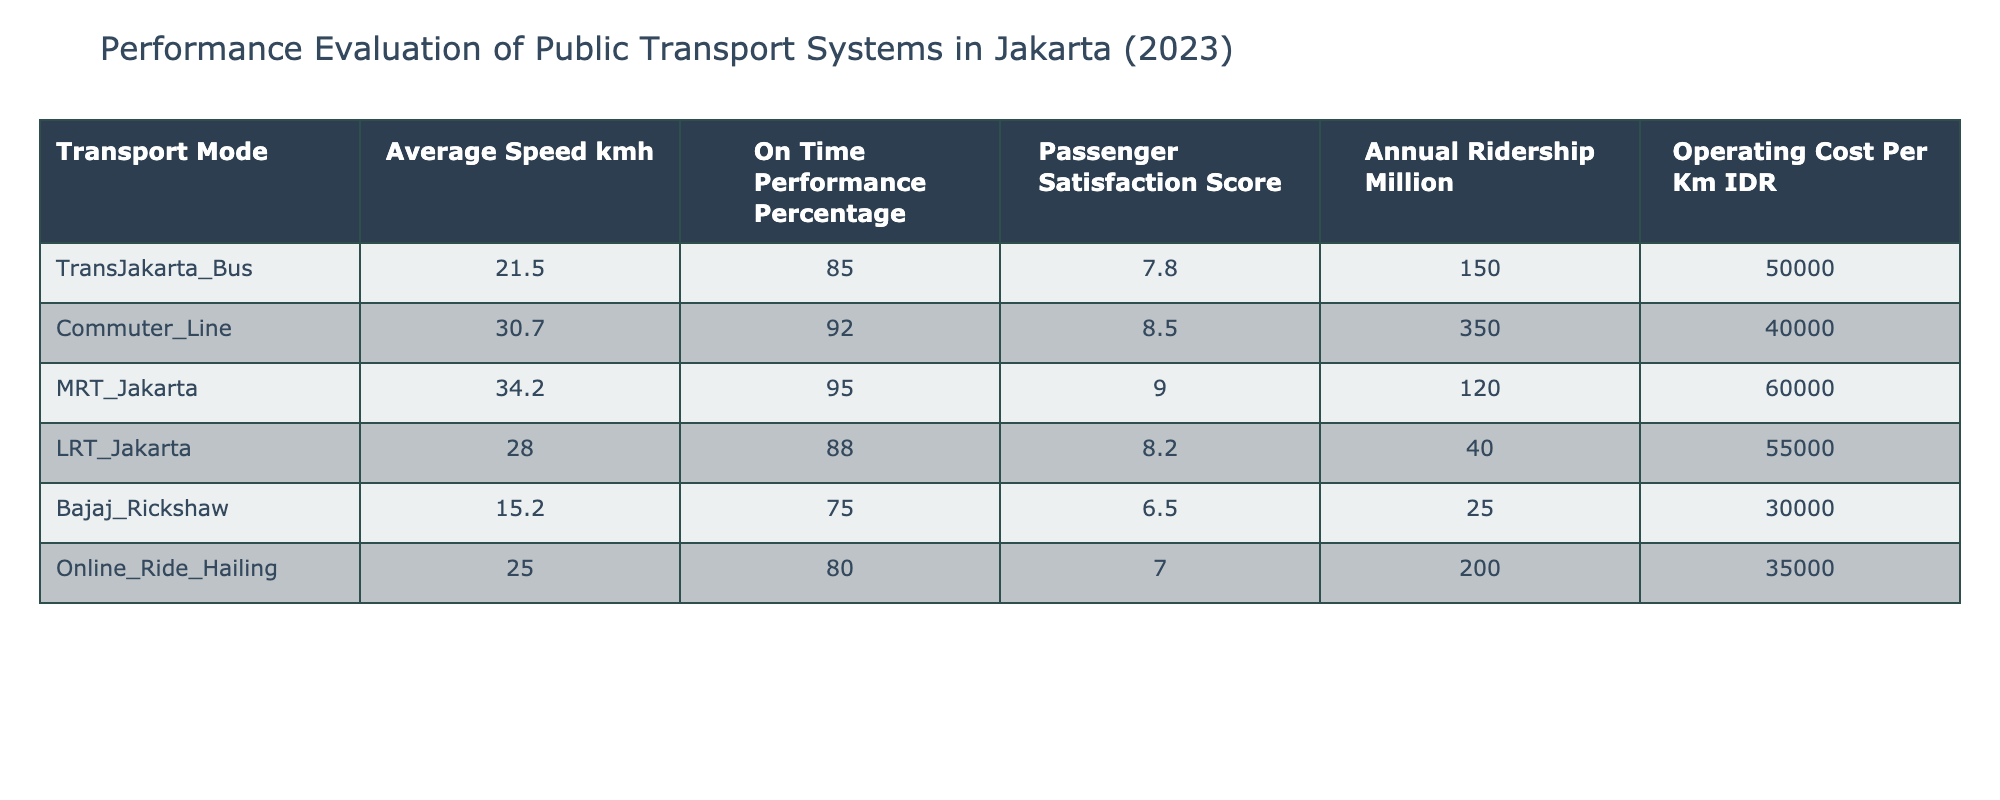What is the average speed of the MRT Jakarta? The table lists the average speed for each transport mode. MRT Jakarta's average speed is indicated as 34.2 km/h.
Answer: 34.2 km/h Which transport mode has the highest passenger satisfaction score? By checking the Passenger Satisfaction Score in the table, the highest score is 9.0 for MRT Jakarta.
Answer: MRT Jakarta What is the on-time performance percentage of the Commuter Line? The On-Time Performance Percentage for the Commuter Line is listed in the table as 92%.
Answer: 92% Which mode of transport has the lowest annual ridership? The Annual Ridership for each transport mode shows that Bajaj Rickshaw has the lowest at 25 million passengers.
Answer: Bajaj Rickshaw If we consider all transport modes, what is the total average speed? To find the total average speed, sum the average speeds: 21.5 + 30.7 + 34.2 + 28.0 + 15.2 + 25.0 = 154.6 km/h. Then divide by the number of modes (6): 154.6 / 6 ≈ 25.77 km/h.
Answer: 25.77 km/h Is the operating cost per kilometer for Online Ride Hailing more than for Bajaj Rickshaw? The operating cost per kilometer for Online Ride Hailing is 35,000 IDR, while for Bajaj Rickshaw it is 30,000 IDR, meaning Online Ride Hailing has a higher cost.
Answer: Yes Which transport mode has the highest operating cost per kilometer? Checking the Operating Cost Per Km column, the MRT Jakarta has the highest cost at 60,000 IDR per km.
Answer: MRT Jakarta What is the difference in annual ridership between the Commuter Line and LRT Jakarta? The Commuter Line's ridership is 350 million and LRT Jakarta's is 40 million. The difference is 350 - 40 = 310 million passengers.
Answer: 310 million What percentage of the transport modes have an on-time performance above 85%? The modes above 85% are Commuter Line (92%), MRT Jakarta (95%), and LRT Jakarta (88%), totaling 3 out of 6 modes. Thus, (3/6) * 100 = 50%.
Answer: 50% 